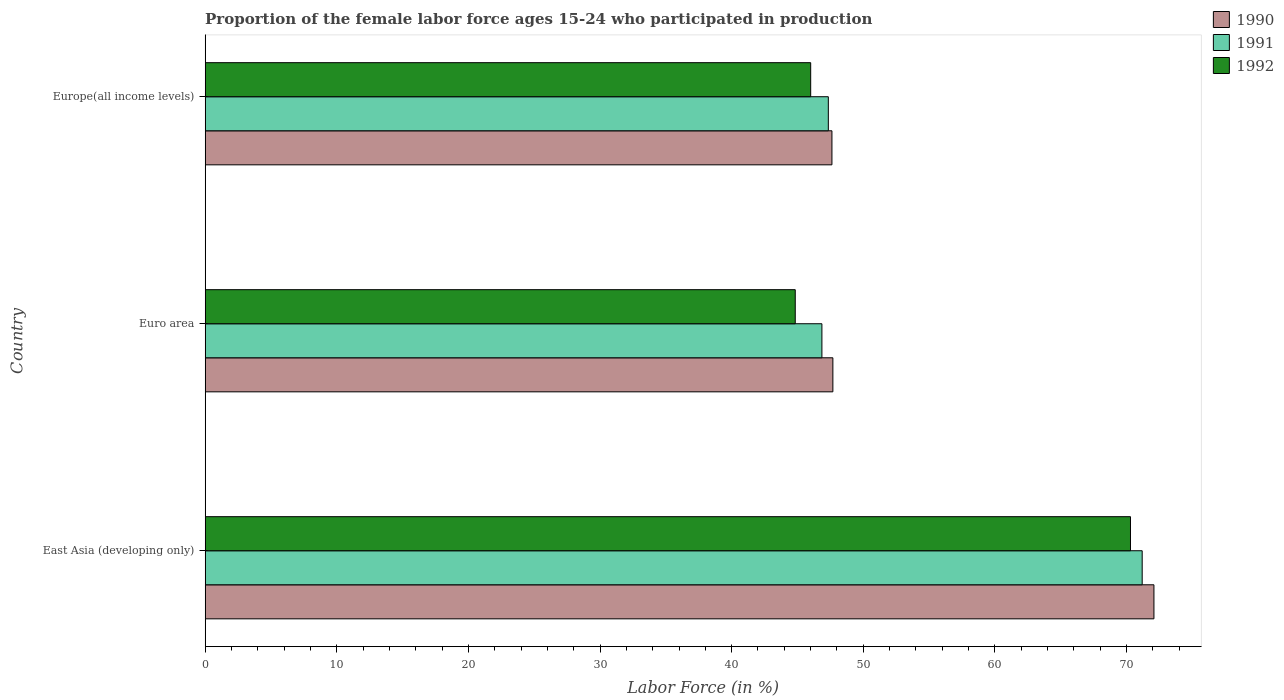Are the number of bars per tick equal to the number of legend labels?
Your response must be concise. Yes. What is the label of the 3rd group of bars from the top?
Your answer should be compact. East Asia (developing only). In how many cases, is the number of bars for a given country not equal to the number of legend labels?
Provide a short and direct response. 0. What is the proportion of the female labor force who participated in production in 1991 in Euro area?
Provide a succinct answer. 46.86. Across all countries, what is the maximum proportion of the female labor force who participated in production in 1991?
Give a very brief answer. 71.19. Across all countries, what is the minimum proportion of the female labor force who participated in production in 1992?
Provide a succinct answer. 44.83. In which country was the proportion of the female labor force who participated in production in 1991 maximum?
Ensure brevity in your answer.  East Asia (developing only). What is the total proportion of the female labor force who participated in production in 1990 in the graph?
Make the answer very short. 167.39. What is the difference between the proportion of the female labor force who participated in production in 1992 in Euro area and that in Europe(all income levels)?
Ensure brevity in your answer.  -1.17. What is the difference between the proportion of the female labor force who participated in production in 1991 in Euro area and the proportion of the female labor force who participated in production in 1992 in Europe(all income levels)?
Offer a terse response. 0.85. What is the average proportion of the female labor force who participated in production in 1990 per country?
Provide a short and direct response. 55.8. What is the difference between the proportion of the female labor force who participated in production in 1990 and proportion of the female labor force who participated in production in 1992 in East Asia (developing only)?
Provide a short and direct response. 1.78. What is the ratio of the proportion of the female labor force who participated in production in 1992 in East Asia (developing only) to that in Europe(all income levels)?
Provide a succinct answer. 1.53. Is the proportion of the female labor force who participated in production in 1991 in East Asia (developing only) less than that in Euro area?
Your answer should be compact. No. What is the difference between the highest and the second highest proportion of the female labor force who participated in production in 1992?
Your response must be concise. 24.3. What is the difference between the highest and the lowest proportion of the female labor force who participated in production in 1990?
Your response must be concise. 24.46. Is the sum of the proportion of the female labor force who participated in production in 1992 in Euro area and Europe(all income levels) greater than the maximum proportion of the female labor force who participated in production in 1990 across all countries?
Make the answer very short. Yes. What does the 1st bar from the top in Europe(all income levels) represents?
Give a very brief answer. 1992. What does the 2nd bar from the bottom in Euro area represents?
Your response must be concise. 1991. Is it the case that in every country, the sum of the proportion of the female labor force who participated in production in 1991 and proportion of the female labor force who participated in production in 1992 is greater than the proportion of the female labor force who participated in production in 1990?
Keep it short and to the point. Yes. Are all the bars in the graph horizontal?
Your response must be concise. Yes. How many countries are there in the graph?
Keep it short and to the point. 3. Are the values on the major ticks of X-axis written in scientific E-notation?
Make the answer very short. No. Does the graph contain any zero values?
Give a very brief answer. No. Does the graph contain grids?
Provide a succinct answer. No. How many legend labels are there?
Your answer should be very brief. 3. What is the title of the graph?
Your answer should be compact. Proportion of the female labor force ages 15-24 who participated in production. What is the label or title of the Y-axis?
Offer a very short reply. Country. What is the Labor Force (in %) of 1990 in East Asia (developing only)?
Keep it short and to the point. 72.08. What is the Labor Force (in %) in 1991 in East Asia (developing only)?
Your answer should be compact. 71.19. What is the Labor Force (in %) of 1992 in East Asia (developing only)?
Provide a short and direct response. 70.3. What is the Labor Force (in %) in 1990 in Euro area?
Ensure brevity in your answer.  47.69. What is the Labor Force (in %) of 1991 in Euro area?
Offer a very short reply. 46.86. What is the Labor Force (in %) of 1992 in Euro area?
Provide a short and direct response. 44.83. What is the Labor Force (in %) in 1990 in Europe(all income levels)?
Your answer should be very brief. 47.62. What is the Labor Force (in %) of 1991 in Europe(all income levels)?
Provide a short and direct response. 47.34. What is the Labor Force (in %) in 1992 in Europe(all income levels)?
Offer a terse response. 46. Across all countries, what is the maximum Labor Force (in %) in 1990?
Provide a short and direct response. 72.08. Across all countries, what is the maximum Labor Force (in %) in 1991?
Ensure brevity in your answer.  71.19. Across all countries, what is the maximum Labor Force (in %) in 1992?
Offer a terse response. 70.3. Across all countries, what is the minimum Labor Force (in %) in 1990?
Keep it short and to the point. 47.62. Across all countries, what is the minimum Labor Force (in %) of 1991?
Ensure brevity in your answer.  46.86. Across all countries, what is the minimum Labor Force (in %) of 1992?
Your response must be concise. 44.83. What is the total Labor Force (in %) in 1990 in the graph?
Your answer should be very brief. 167.39. What is the total Labor Force (in %) of 1991 in the graph?
Your answer should be very brief. 165.39. What is the total Labor Force (in %) in 1992 in the graph?
Give a very brief answer. 161.14. What is the difference between the Labor Force (in %) in 1990 in East Asia (developing only) and that in Euro area?
Provide a short and direct response. 24.39. What is the difference between the Labor Force (in %) of 1991 in East Asia (developing only) and that in Euro area?
Give a very brief answer. 24.34. What is the difference between the Labor Force (in %) in 1992 in East Asia (developing only) and that in Euro area?
Ensure brevity in your answer.  25.47. What is the difference between the Labor Force (in %) of 1990 in East Asia (developing only) and that in Europe(all income levels)?
Your answer should be compact. 24.46. What is the difference between the Labor Force (in %) in 1991 in East Asia (developing only) and that in Europe(all income levels)?
Offer a very short reply. 23.85. What is the difference between the Labor Force (in %) in 1992 in East Asia (developing only) and that in Europe(all income levels)?
Offer a very short reply. 24.3. What is the difference between the Labor Force (in %) in 1990 in Euro area and that in Europe(all income levels)?
Keep it short and to the point. 0.07. What is the difference between the Labor Force (in %) in 1991 in Euro area and that in Europe(all income levels)?
Ensure brevity in your answer.  -0.49. What is the difference between the Labor Force (in %) of 1992 in Euro area and that in Europe(all income levels)?
Make the answer very short. -1.17. What is the difference between the Labor Force (in %) in 1990 in East Asia (developing only) and the Labor Force (in %) in 1991 in Euro area?
Provide a short and direct response. 25.23. What is the difference between the Labor Force (in %) in 1990 in East Asia (developing only) and the Labor Force (in %) in 1992 in Euro area?
Make the answer very short. 27.25. What is the difference between the Labor Force (in %) of 1991 in East Asia (developing only) and the Labor Force (in %) of 1992 in Euro area?
Keep it short and to the point. 26.36. What is the difference between the Labor Force (in %) of 1990 in East Asia (developing only) and the Labor Force (in %) of 1991 in Europe(all income levels)?
Ensure brevity in your answer.  24.74. What is the difference between the Labor Force (in %) in 1990 in East Asia (developing only) and the Labor Force (in %) in 1992 in Europe(all income levels)?
Offer a terse response. 26.08. What is the difference between the Labor Force (in %) in 1991 in East Asia (developing only) and the Labor Force (in %) in 1992 in Europe(all income levels)?
Your answer should be very brief. 25.19. What is the difference between the Labor Force (in %) of 1990 in Euro area and the Labor Force (in %) of 1991 in Europe(all income levels)?
Offer a terse response. 0.35. What is the difference between the Labor Force (in %) in 1990 in Euro area and the Labor Force (in %) in 1992 in Europe(all income levels)?
Provide a succinct answer. 1.69. What is the difference between the Labor Force (in %) in 1991 in Euro area and the Labor Force (in %) in 1992 in Europe(all income levels)?
Offer a very short reply. 0.85. What is the average Labor Force (in %) in 1990 per country?
Your answer should be compact. 55.8. What is the average Labor Force (in %) of 1991 per country?
Ensure brevity in your answer.  55.13. What is the average Labor Force (in %) of 1992 per country?
Offer a terse response. 53.71. What is the difference between the Labor Force (in %) of 1990 and Labor Force (in %) of 1991 in East Asia (developing only)?
Your answer should be compact. 0.89. What is the difference between the Labor Force (in %) of 1990 and Labor Force (in %) of 1992 in East Asia (developing only)?
Offer a very short reply. 1.78. What is the difference between the Labor Force (in %) of 1990 and Labor Force (in %) of 1991 in Euro area?
Your answer should be compact. 0.83. What is the difference between the Labor Force (in %) of 1990 and Labor Force (in %) of 1992 in Euro area?
Your answer should be very brief. 2.86. What is the difference between the Labor Force (in %) in 1991 and Labor Force (in %) in 1992 in Euro area?
Your response must be concise. 2.02. What is the difference between the Labor Force (in %) in 1990 and Labor Force (in %) in 1991 in Europe(all income levels)?
Your response must be concise. 0.27. What is the difference between the Labor Force (in %) of 1990 and Labor Force (in %) of 1992 in Europe(all income levels)?
Offer a very short reply. 1.61. What is the difference between the Labor Force (in %) of 1991 and Labor Force (in %) of 1992 in Europe(all income levels)?
Ensure brevity in your answer.  1.34. What is the ratio of the Labor Force (in %) in 1990 in East Asia (developing only) to that in Euro area?
Provide a succinct answer. 1.51. What is the ratio of the Labor Force (in %) in 1991 in East Asia (developing only) to that in Euro area?
Make the answer very short. 1.52. What is the ratio of the Labor Force (in %) of 1992 in East Asia (developing only) to that in Euro area?
Provide a short and direct response. 1.57. What is the ratio of the Labor Force (in %) in 1990 in East Asia (developing only) to that in Europe(all income levels)?
Provide a succinct answer. 1.51. What is the ratio of the Labor Force (in %) in 1991 in East Asia (developing only) to that in Europe(all income levels)?
Ensure brevity in your answer.  1.5. What is the ratio of the Labor Force (in %) of 1992 in East Asia (developing only) to that in Europe(all income levels)?
Keep it short and to the point. 1.53. What is the ratio of the Labor Force (in %) in 1990 in Euro area to that in Europe(all income levels)?
Your response must be concise. 1. What is the ratio of the Labor Force (in %) in 1992 in Euro area to that in Europe(all income levels)?
Your answer should be compact. 0.97. What is the difference between the highest and the second highest Labor Force (in %) in 1990?
Your response must be concise. 24.39. What is the difference between the highest and the second highest Labor Force (in %) in 1991?
Offer a very short reply. 23.85. What is the difference between the highest and the second highest Labor Force (in %) in 1992?
Offer a very short reply. 24.3. What is the difference between the highest and the lowest Labor Force (in %) of 1990?
Provide a succinct answer. 24.46. What is the difference between the highest and the lowest Labor Force (in %) in 1991?
Offer a very short reply. 24.34. What is the difference between the highest and the lowest Labor Force (in %) of 1992?
Your answer should be very brief. 25.47. 